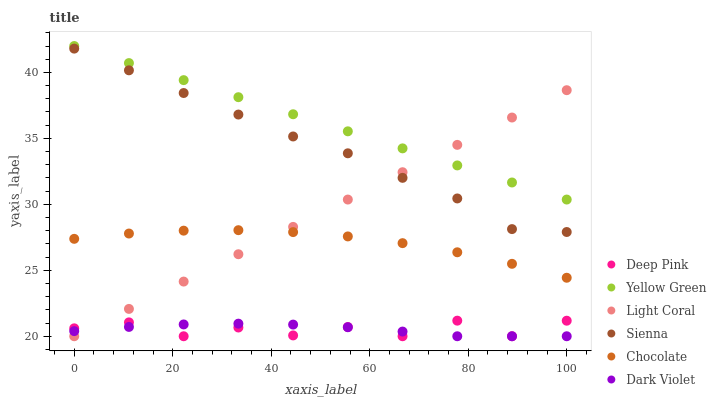Does Deep Pink have the minimum area under the curve?
Answer yes or no. Yes. Does Yellow Green have the maximum area under the curve?
Answer yes or no. Yes. Does Yellow Green have the minimum area under the curve?
Answer yes or no. No. Does Deep Pink have the maximum area under the curve?
Answer yes or no. No. Is Yellow Green the smoothest?
Answer yes or no. Yes. Is Deep Pink the roughest?
Answer yes or no. Yes. Is Deep Pink the smoothest?
Answer yes or no. No. Is Yellow Green the roughest?
Answer yes or no. No. Does Deep Pink have the lowest value?
Answer yes or no. Yes. Does Yellow Green have the lowest value?
Answer yes or no. No. Does Yellow Green have the highest value?
Answer yes or no. Yes. Does Deep Pink have the highest value?
Answer yes or no. No. Is Deep Pink less than Sienna?
Answer yes or no. Yes. Is Yellow Green greater than Sienna?
Answer yes or no. Yes. Does Chocolate intersect Light Coral?
Answer yes or no. Yes. Is Chocolate less than Light Coral?
Answer yes or no. No. Is Chocolate greater than Light Coral?
Answer yes or no. No. Does Deep Pink intersect Sienna?
Answer yes or no. No. 